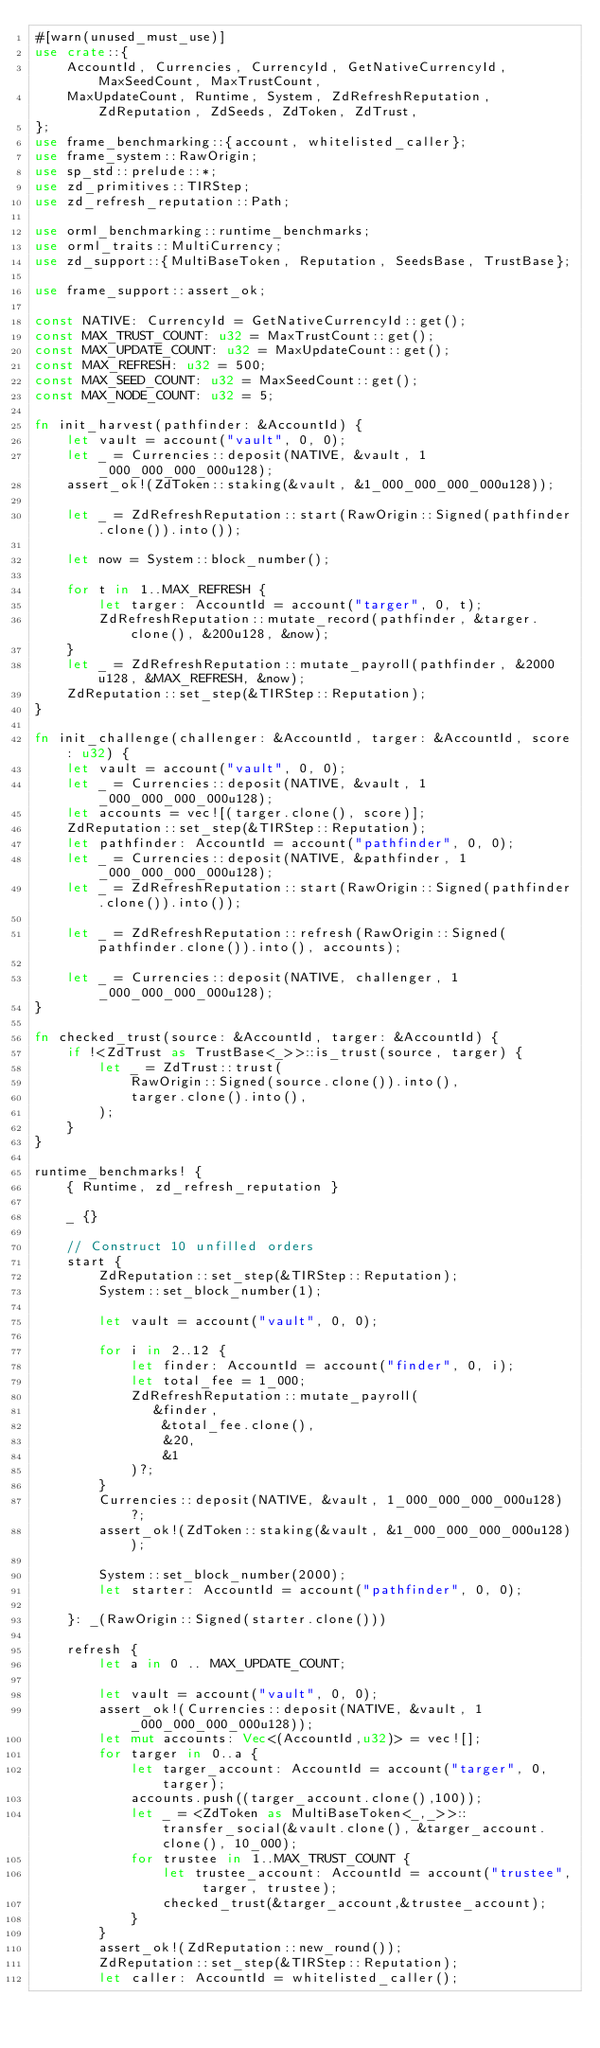<code> <loc_0><loc_0><loc_500><loc_500><_Rust_>#[warn(unused_must_use)]
use crate::{
    AccountId, Currencies, CurrencyId, GetNativeCurrencyId, MaxSeedCount, MaxTrustCount,
    MaxUpdateCount, Runtime, System, ZdRefreshReputation, ZdReputation, ZdSeeds, ZdToken, ZdTrust,
};
use frame_benchmarking::{account, whitelisted_caller};
use frame_system::RawOrigin;
use sp_std::prelude::*;
use zd_primitives::TIRStep;
use zd_refresh_reputation::Path;

use orml_benchmarking::runtime_benchmarks;
use orml_traits::MultiCurrency;
use zd_support::{MultiBaseToken, Reputation, SeedsBase, TrustBase};

use frame_support::assert_ok;

const NATIVE: CurrencyId = GetNativeCurrencyId::get();
const MAX_TRUST_COUNT: u32 = MaxTrustCount::get();
const MAX_UPDATE_COUNT: u32 = MaxUpdateCount::get();
const MAX_REFRESH: u32 = 500;
const MAX_SEED_COUNT: u32 = MaxSeedCount::get();
const MAX_NODE_COUNT: u32 = 5;

fn init_harvest(pathfinder: &AccountId) {
    let vault = account("vault", 0, 0);
    let _ = Currencies::deposit(NATIVE, &vault, 1_000_000_000_000u128);
    assert_ok!(ZdToken::staking(&vault, &1_000_000_000_000u128));

    let _ = ZdRefreshReputation::start(RawOrigin::Signed(pathfinder.clone()).into());

    let now = System::block_number();

    for t in 1..MAX_REFRESH {
        let targer: AccountId = account("targer", 0, t);
        ZdRefreshReputation::mutate_record(pathfinder, &targer.clone(), &200u128, &now);
    }
    let _ = ZdRefreshReputation::mutate_payroll(pathfinder, &2000u128, &MAX_REFRESH, &now);
    ZdReputation::set_step(&TIRStep::Reputation);
}

fn init_challenge(challenger: &AccountId, targer: &AccountId, score: u32) {
    let vault = account("vault", 0, 0);
    let _ = Currencies::deposit(NATIVE, &vault, 1_000_000_000_000u128);
    let accounts = vec![(targer.clone(), score)];
    ZdReputation::set_step(&TIRStep::Reputation);
    let pathfinder: AccountId = account("pathfinder", 0, 0);
    let _ = Currencies::deposit(NATIVE, &pathfinder, 1_000_000_000_000u128);
    let _ = ZdRefreshReputation::start(RawOrigin::Signed(pathfinder.clone()).into());

    let _ = ZdRefreshReputation::refresh(RawOrigin::Signed(pathfinder.clone()).into(), accounts);

    let _ = Currencies::deposit(NATIVE, challenger, 1_000_000_000_000u128);
}

fn checked_trust(source: &AccountId, targer: &AccountId) {
    if !<ZdTrust as TrustBase<_>>::is_trust(source, targer) {
        let _ = ZdTrust::trust(
            RawOrigin::Signed(source.clone()).into(),
            targer.clone().into(),
        );
    }
}

runtime_benchmarks! {
    { Runtime, zd_refresh_reputation }

    _ {}

    // Construct 10 unfilled orders
    start {
        ZdReputation::set_step(&TIRStep::Reputation);
        System::set_block_number(1);

        let vault = account("vault", 0, 0);

        for i in 2..12 {
            let finder: AccountId = account("finder", 0, i);
            let total_fee = 1_000;
            ZdRefreshReputation::mutate_payroll(
               &finder,
                &total_fee.clone(),
                &20,
                &1
            )?;
        }
        Currencies::deposit(NATIVE, &vault, 1_000_000_000_000u128)?;
        assert_ok!(ZdToken::staking(&vault, &1_000_000_000_000u128));

        System::set_block_number(2000);
        let starter: AccountId = account("pathfinder", 0, 0);

    }: _(RawOrigin::Signed(starter.clone()))

    refresh {
        let a in 0 .. MAX_UPDATE_COUNT;

        let vault = account("vault", 0, 0);
        assert_ok!(Currencies::deposit(NATIVE, &vault, 1_000_000_000_000u128));
        let mut accounts: Vec<(AccountId,u32)> = vec![];
        for targer in 0..a {
            let targer_account: AccountId = account("targer", 0, targer);
            accounts.push((targer_account.clone(),100));
            let _ = <ZdToken as MultiBaseToken<_,_>>::transfer_social(&vault.clone(), &targer_account.clone(), 10_000);
            for trustee in 1..MAX_TRUST_COUNT {
                let trustee_account: AccountId = account("trustee", targer, trustee);
                checked_trust(&targer_account,&trustee_account);
            }
        }
        assert_ok!(ZdReputation::new_round());
        ZdReputation::set_step(&TIRStep::Reputation);
        let caller: AccountId = whitelisted_caller();</code> 